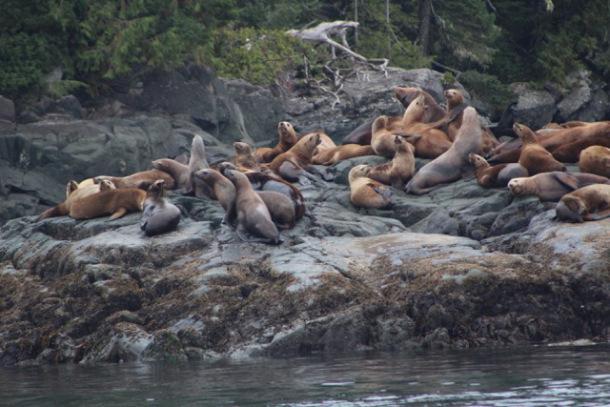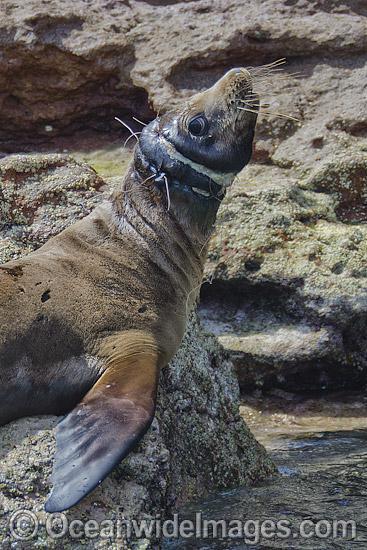The first image is the image on the left, the second image is the image on the right. Assess this claim about the two images: "a single animal is on a rock in the right pic". Correct or not? Answer yes or no. Yes. The first image is the image on the left, the second image is the image on the right. Examine the images to the left and right. Is the description "In one image, a seal is in the water." accurate? Answer yes or no. No. 